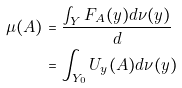<formula> <loc_0><loc_0><loc_500><loc_500>\mu ( A ) & = \frac { \int _ { Y } F _ { A } ( y ) d \nu ( y ) } { d } \\ & = \int _ { Y _ { 0 } } U _ { y } ( A ) d \nu ( y )</formula> 